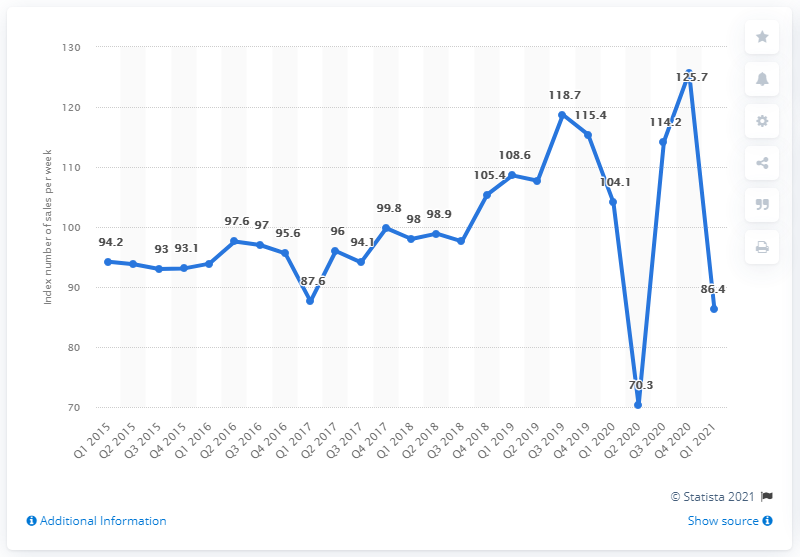Highlight a few significant elements in this photo. In the fourth quarter of 2020, the value index was measured at 125.7. 